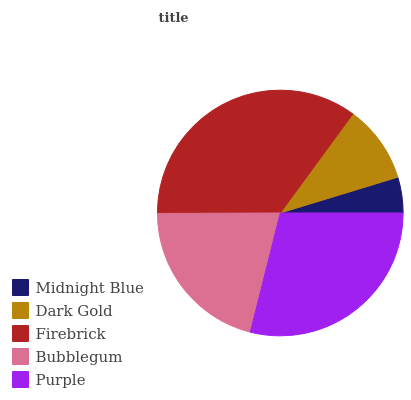Is Midnight Blue the minimum?
Answer yes or no. Yes. Is Firebrick the maximum?
Answer yes or no. Yes. Is Dark Gold the minimum?
Answer yes or no. No. Is Dark Gold the maximum?
Answer yes or no. No. Is Dark Gold greater than Midnight Blue?
Answer yes or no. Yes. Is Midnight Blue less than Dark Gold?
Answer yes or no. Yes. Is Midnight Blue greater than Dark Gold?
Answer yes or no. No. Is Dark Gold less than Midnight Blue?
Answer yes or no. No. Is Bubblegum the high median?
Answer yes or no. Yes. Is Bubblegum the low median?
Answer yes or no. Yes. Is Midnight Blue the high median?
Answer yes or no. No. Is Midnight Blue the low median?
Answer yes or no. No. 